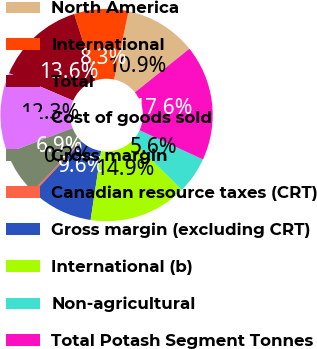<chart> <loc_0><loc_0><loc_500><loc_500><pie_chart><fcel>North America<fcel>International<fcel>Total<fcel>Cost of goods sold<fcel>Gross margin<fcel>Canadian resource taxes (CRT)<fcel>Gross margin (excluding CRT)<fcel>International (b)<fcel>Non-agricultural<fcel>Total Potash Segment Tonnes<nl><fcel>10.93%<fcel>8.26%<fcel>13.6%<fcel>12.27%<fcel>6.93%<fcel>0.26%<fcel>9.6%<fcel>14.94%<fcel>5.59%<fcel>17.61%<nl></chart> 